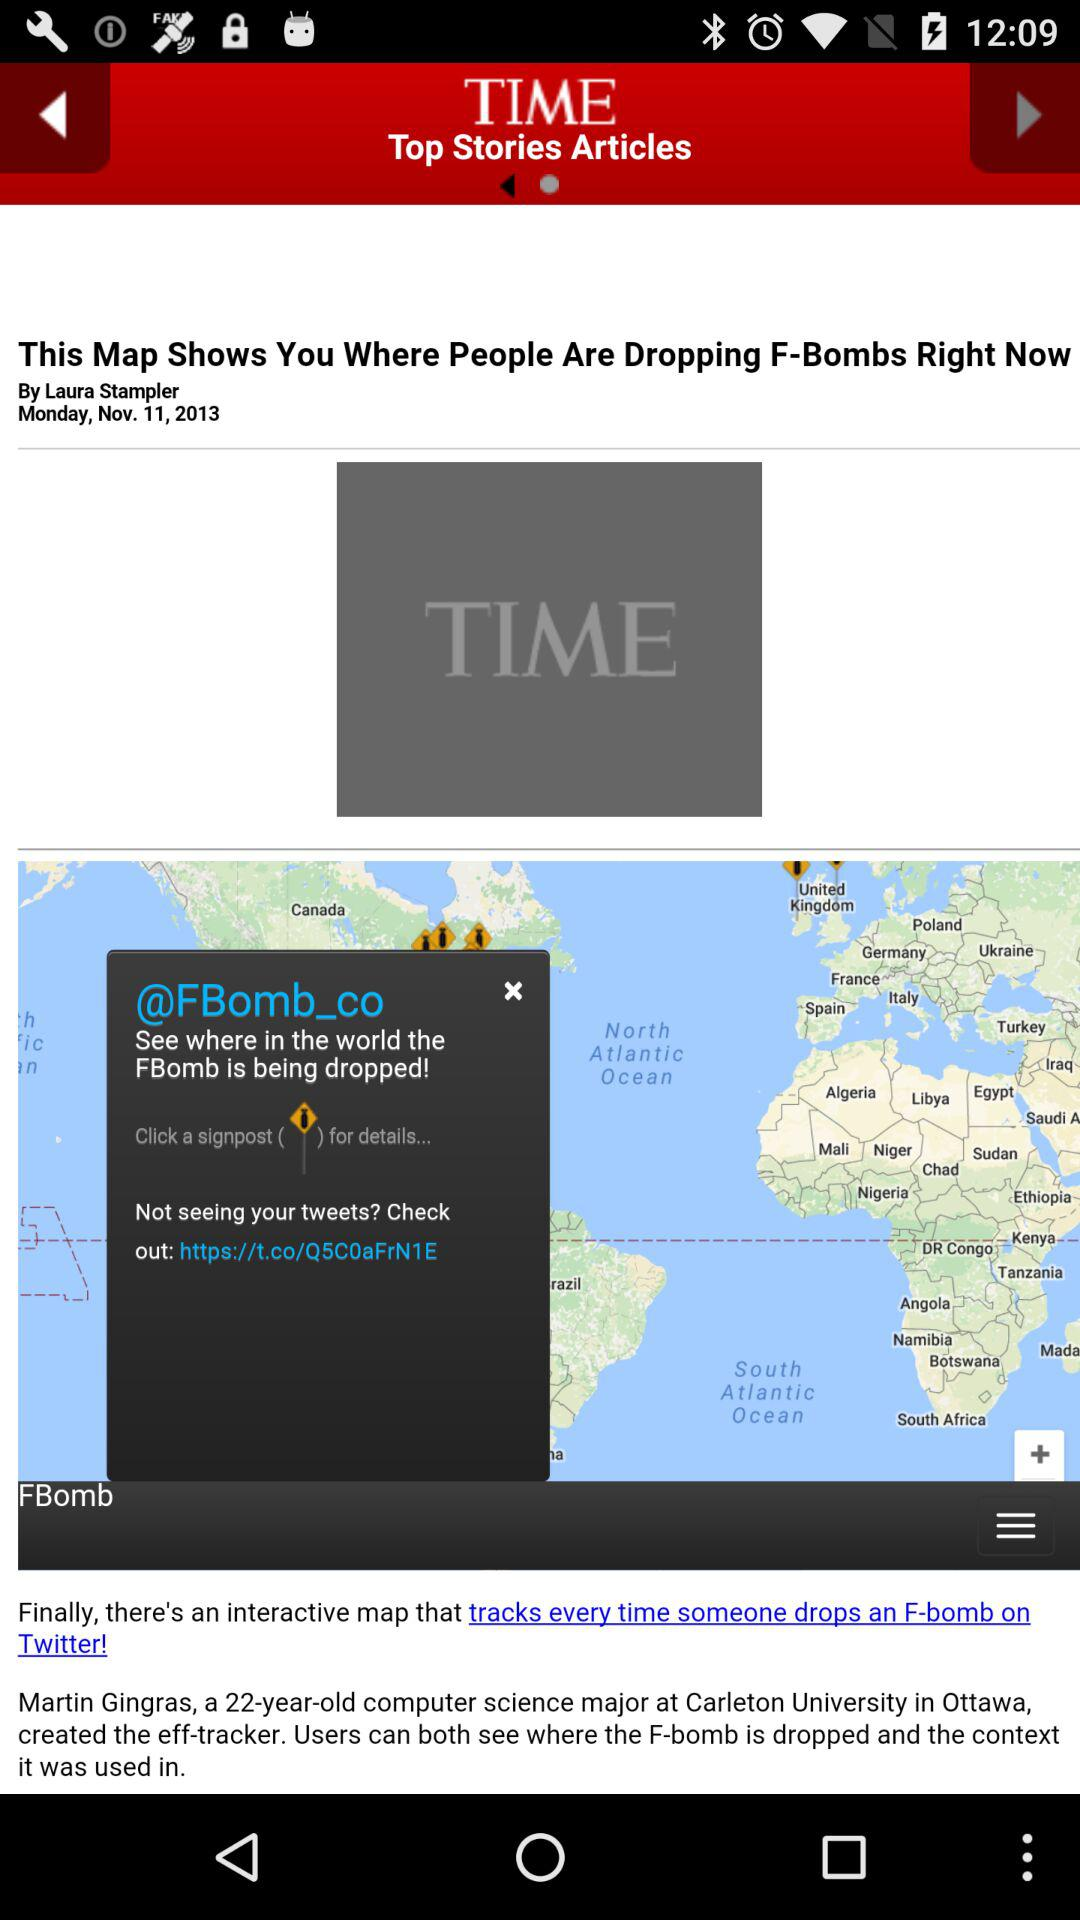What is the author's name? The author's name is Laura Stampler. 